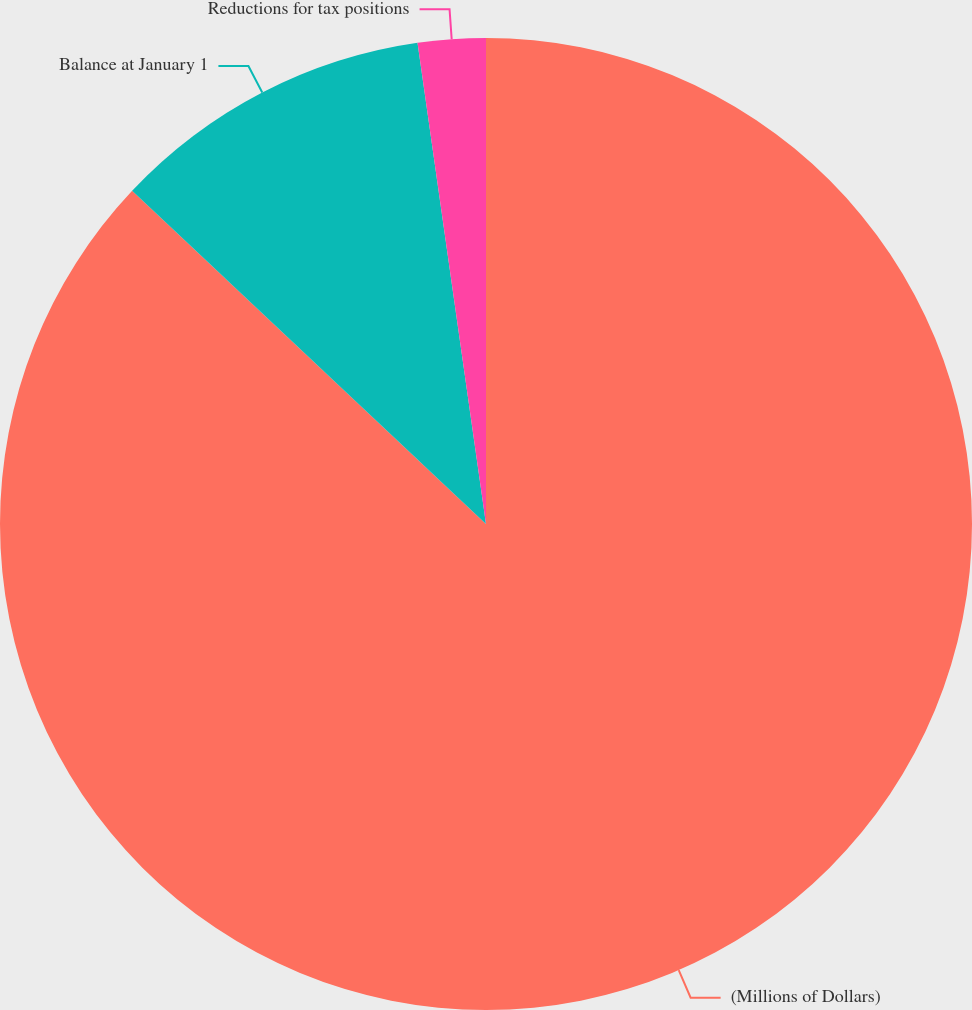Convert chart to OTSL. <chart><loc_0><loc_0><loc_500><loc_500><pie_chart><fcel>(Millions of Dollars)<fcel>Balance at January 1<fcel>Reductions for tax positions<nl><fcel>87.02%<fcel>10.73%<fcel>2.25%<nl></chart> 